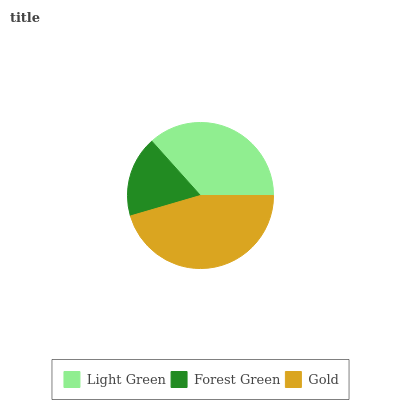Is Forest Green the minimum?
Answer yes or no. Yes. Is Gold the maximum?
Answer yes or no. Yes. Is Gold the minimum?
Answer yes or no. No. Is Forest Green the maximum?
Answer yes or no. No. Is Gold greater than Forest Green?
Answer yes or no. Yes. Is Forest Green less than Gold?
Answer yes or no. Yes. Is Forest Green greater than Gold?
Answer yes or no. No. Is Gold less than Forest Green?
Answer yes or no. No. Is Light Green the high median?
Answer yes or no. Yes. Is Light Green the low median?
Answer yes or no. Yes. Is Forest Green the high median?
Answer yes or no. No. Is Gold the low median?
Answer yes or no. No. 